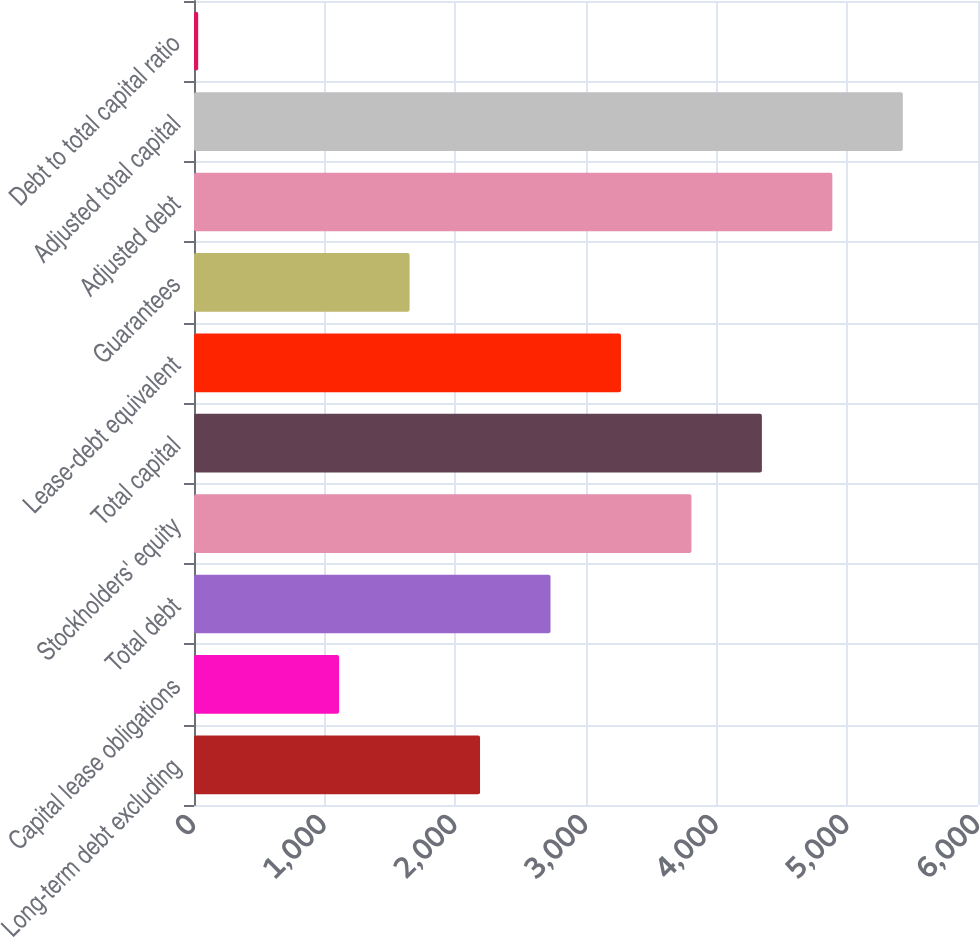<chart> <loc_0><loc_0><loc_500><loc_500><bar_chart><fcel>Long-term debt excluding<fcel>Capital lease obligations<fcel>Total debt<fcel>Stockholders' equity<fcel>Total capital<fcel>Lease-debt equivalent<fcel>Guarantees<fcel>Adjusted debt<fcel>Adjusted total capital<fcel>Debt to total capital ratio<nl><fcel>2189.04<fcel>1110.52<fcel>2728.3<fcel>3806.82<fcel>4346.08<fcel>3267.56<fcel>1649.78<fcel>4885.34<fcel>5424.6<fcel>32<nl></chart> 